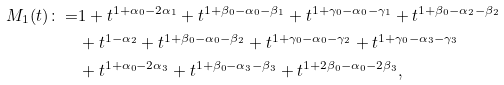Convert formula to latex. <formula><loc_0><loc_0><loc_500><loc_500>M _ { 1 } ( t ) \colon = & 1 + t ^ { 1 + \alpha _ { 0 } - 2 \alpha _ { 1 } } + t ^ { 1 + \beta _ { 0 } - \alpha _ { 0 } - \beta _ { 1 } } + t ^ { 1 + \gamma _ { 0 } - \alpha _ { 0 } - \gamma _ { 1 } } + t ^ { 1 + \beta _ { 0 } - \alpha _ { 2 } - \beta _ { 2 } } \\ & + t ^ { 1 - \alpha _ { 2 } } + t ^ { 1 + \beta _ { 0 } - \alpha _ { 0 } - \beta _ { 2 } } + t ^ { 1 + \gamma _ { 0 } - \alpha _ { 0 } - \gamma _ { 2 } } + t ^ { 1 + \gamma _ { 0 } - \alpha _ { 3 } - \gamma _ { 3 } } \\ & + t ^ { 1 + \alpha _ { 0 } - 2 \alpha _ { 3 } } + t ^ { 1 + \beta _ { 0 } - \alpha _ { 3 } - \beta _ { 3 } } + t ^ { 1 + 2 \beta _ { 0 } - \alpha _ { 0 } - 2 \beta _ { 3 } } ,</formula> 